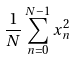Convert formula to latex. <formula><loc_0><loc_0><loc_500><loc_500>\frac { 1 } { N } \sum _ { n = 0 } ^ { N - 1 } x _ { n } ^ { 2 }</formula> 